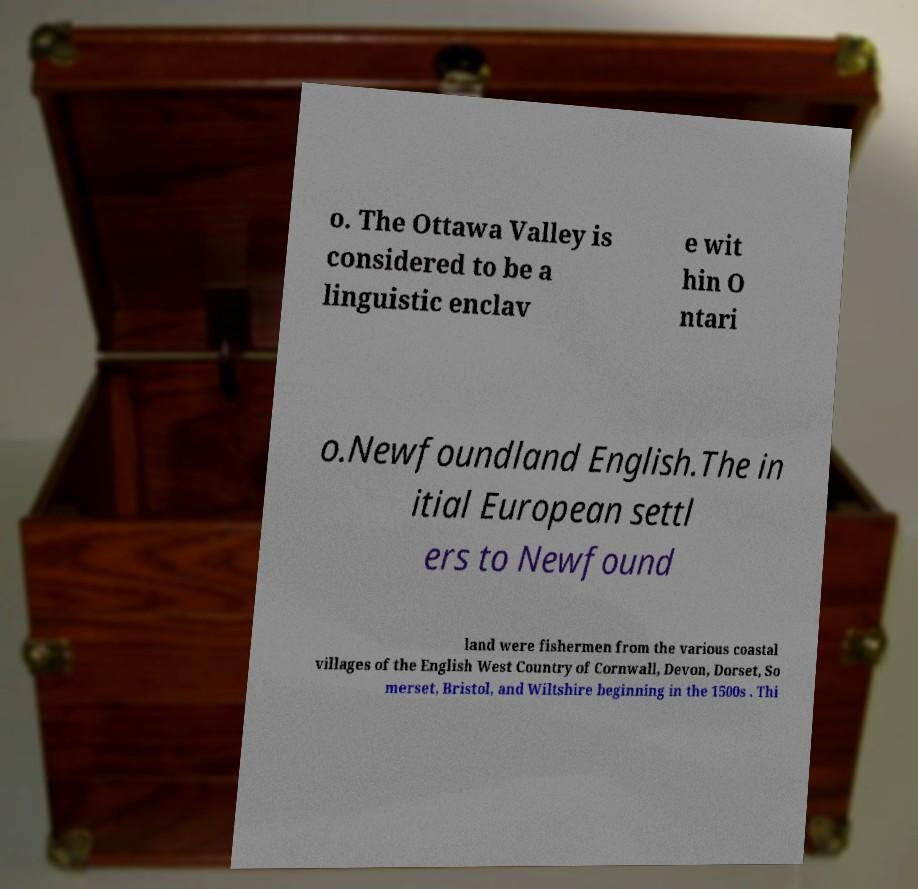Can you read and provide the text displayed in the image?This photo seems to have some interesting text. Can you extract and type it out for me? o. The Ottawa Valley is considered to be a linguistic enclav e wit hin O ntari o.Newfoundland English.The in itial European settl ers to Newfound land were fishermen from the various coastal villages of the English West Country of Cornwall, Devon, Dorset, So merset, Bristol, and Wiltshire beginning in the 1500s . Thi 